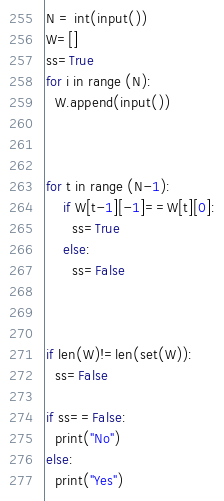Convert code to text. <code><loc_0><loc_0><loc_500><loc_500><_Python_>N = int(input())
W=[]
ss=True
for i in range (N):
  W.append(input())



for t in range (N-1):
    if W[t-1][-1]==W[t][0]:
      ss=True
    else:
      ss=False 
     
      

if len(W)!=len(set(W)):   
  ss=False
     
if ss==False:
  print("No")
else:
  print("Yes")
</code> 